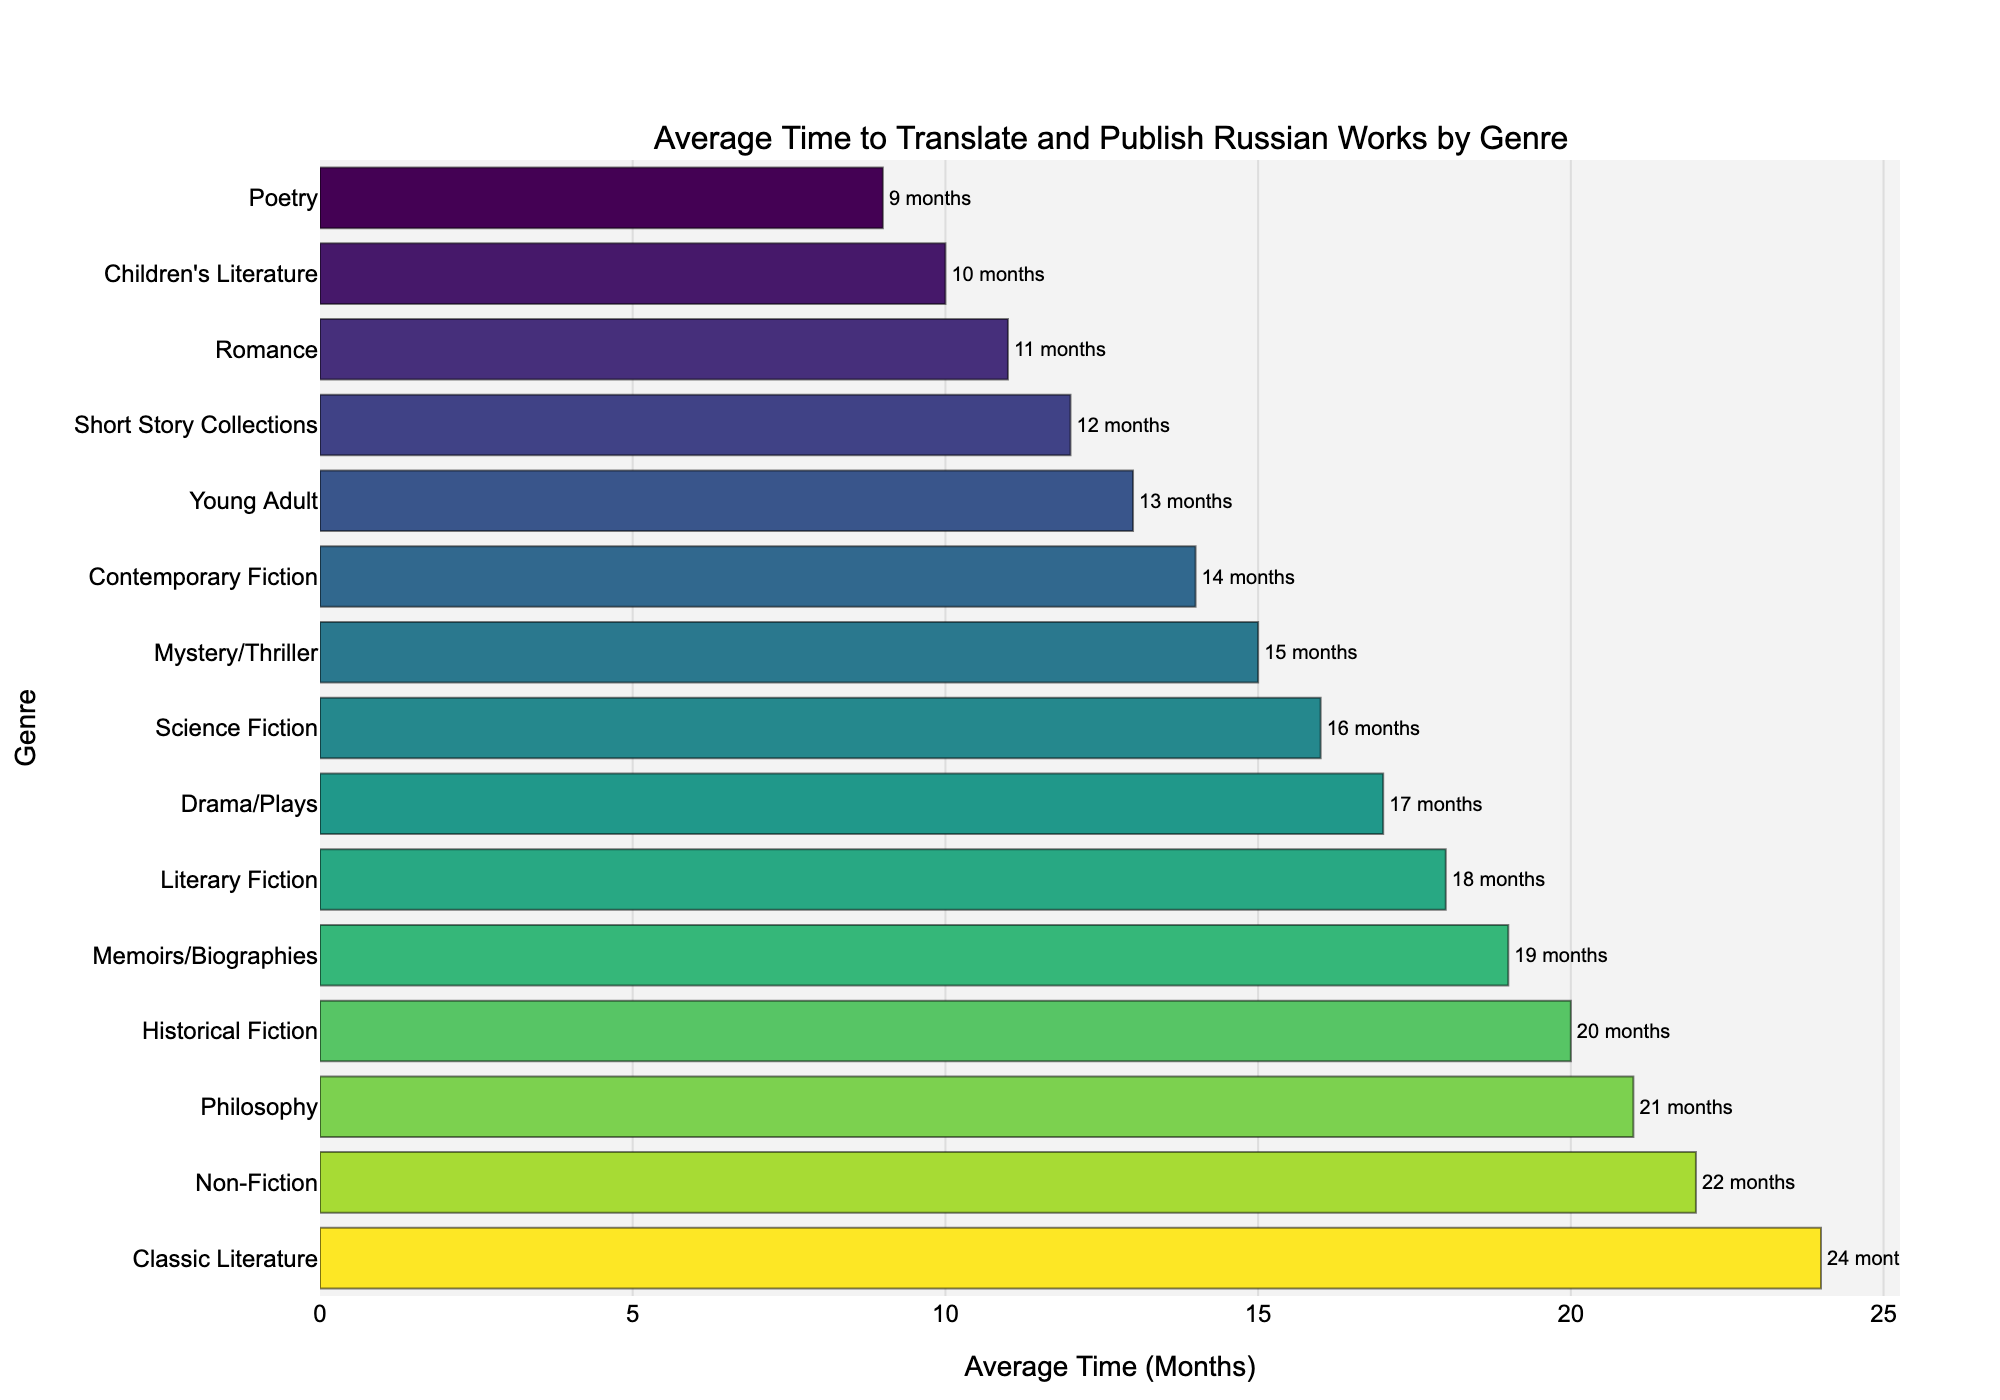What genre takes the longest to translate and publish? Look at the bar chart and identify the genre with the highest bar. This corresponds to the longest average time.
Answer: Classic Literature Which genre takes the shortest time to translate and publish? Look at the bar chart and identify the genre with the smallest bar. This corresponds to the shortest average time.
Answer: Poetry How much longer does it take to translate and publish Classic Literature compared to Children's Literature? Find the average times for both genres and subtract Children's Literature's average time from Classic Literature's average time. Classic Literature is 24 months and Children's Literature is 10 months. 24 - 10 = 14 months.
Answer: 14 months What is the average time taken to translate and publish Short Story Collections and Contemporary Fiction? Find the average times for both genres and calculate their average. (12 months for Short Story Collections + 14 months for Contemporary Fiction) / 2 = 13 months.
Answer: 13 months Are there any genres that take the same average time to translate and publish? Check the lengths of the bars and find if any genres have the same length or value. There are no genres in the chart that take exactly the same average time.
Answer: No Which genre takes more time to translate and publish: Memoirs/Biographies or Drama/Plays? Compare the lengths of the bars for Memoirs/Biographies (19 months) and Drama/Plays (17 months). Memoirs/Biographies takes longer.
Answer: Memoirs/Biographies What is the difference in average time taken to translate and publish Non-Fiction and Romance genres? Subtract the average time of the Romance genre (11 months) from the average time of the Non-Fiction genre (22 months). 22 - 11 = 11 months.
Answer: 11 months Rank the top three genres by the Average Time (Months) taken to translate and publish. Identify and list the three genres with the longest bars.
Answer: Classic Literature, Non-Fiction, Philosophy Which genre among Mystery/Thriller, Science Fiction, and Romance takes the longest to translate and publish? Compare the average times: Mystery/Thriller (15 months), Science Fiction (16 months), and Romance (11 months). Science Fiction takes the longest.
Answer: Science Fiction Which genre is translated and published faster on average: Literary Fiction or Young Adult? Compare the average times for Literary Fiction (18 months) and Young Adult (13 months). Young Adult is faster.
Answer: Young Adult 